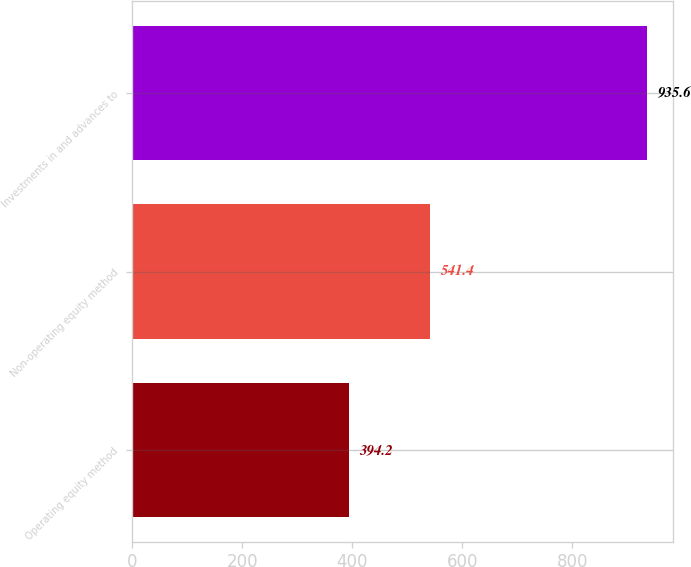Convert chart to OTSL. <chart><loc_0><loc_0><loc_500><loc_500><bar_chart><fcel>Operating equity method<fcel>Non-operating equity method<fcel>Investments in and advances to<nl><fcel>394.2<fcel>541.4<fcel>935.6<nl></chart> 